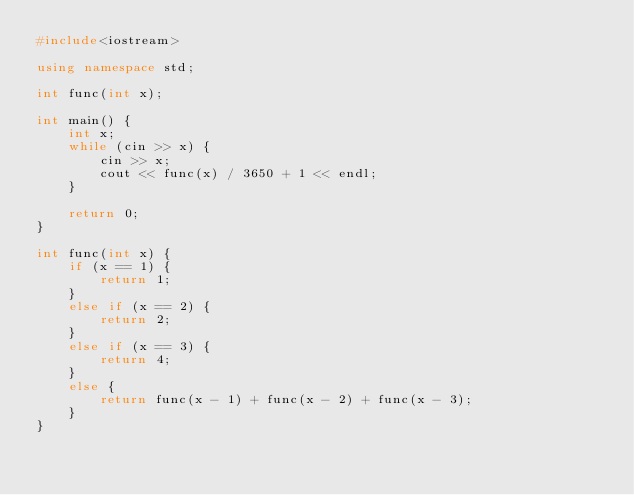<code> <loc_0><loc_0><loc_500><loc_500><_C++_>#include<iostream>

using namespace std;

int func(int x);

int main() {
	int x;
	while (cin >> x) {
		cin >> x;
		cout << func(x) / 3650 + 1 << endl;
	}
	
	return 0;
}

int func(int x) {
	if (x == 1) {
		return 1;
	}
	else if (x == 2) {
		return 2;
	}
	else if (x == 3) {
		return 4;
	}
	else {
		return func(x - 1) + func(x - 2) + func(x - 3);
	}
}</code> 